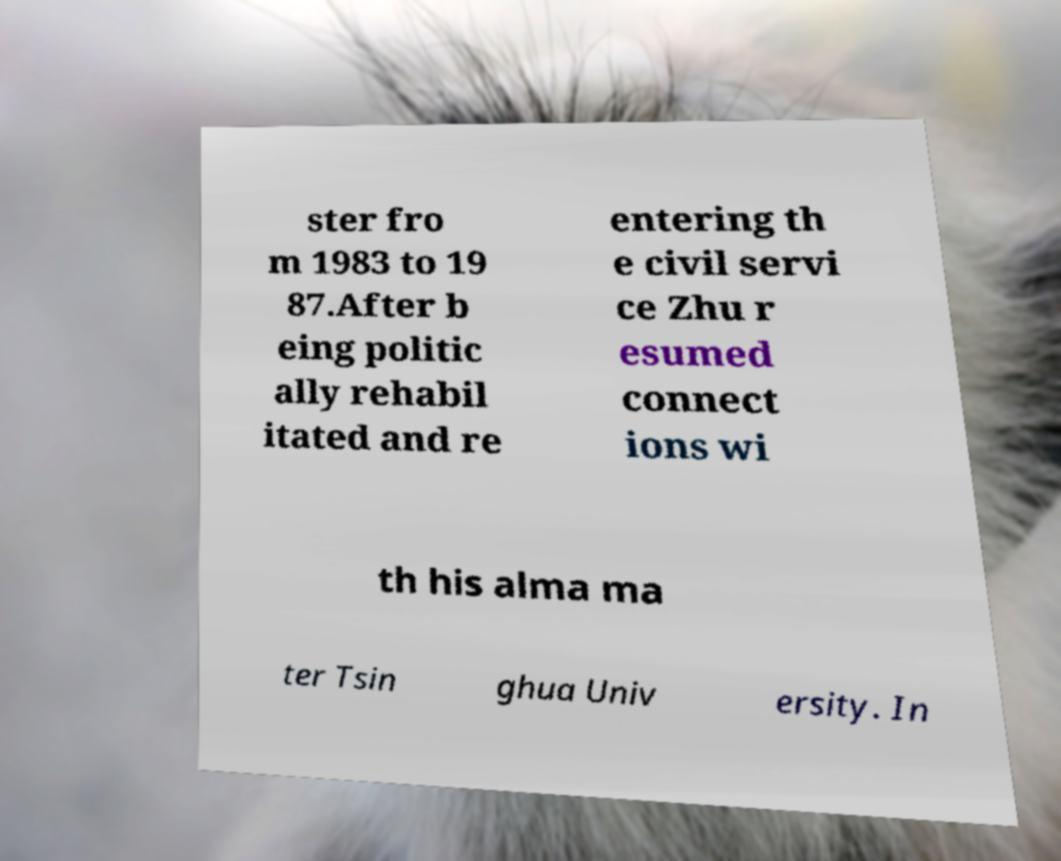Please read and relay the text visible in this image. What does it say? ster fro m 1983 to 19 87.After b eing politic ally rehabil itated and re entering th e civil servi ce Zhu r esumed connect ions wi th his alma ma ter Tsin ghua Univ ersity. In 